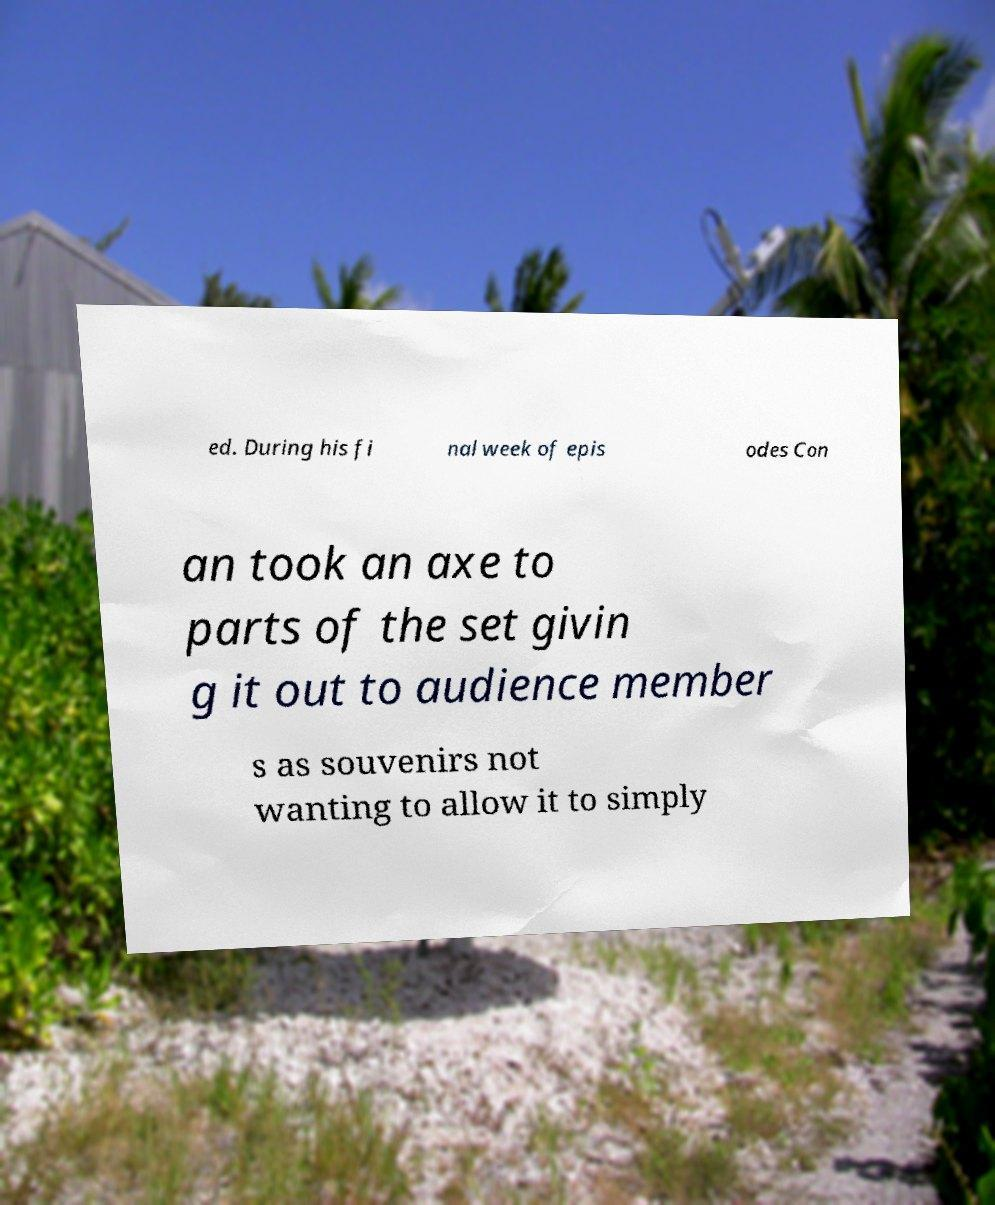Please identify and transcribe the text found in this image. ed. During his fi nal week of epis odes Con an took an axe to parts of the set givin g it out to audience member s as souvenirs not wanting to allow it to simply 